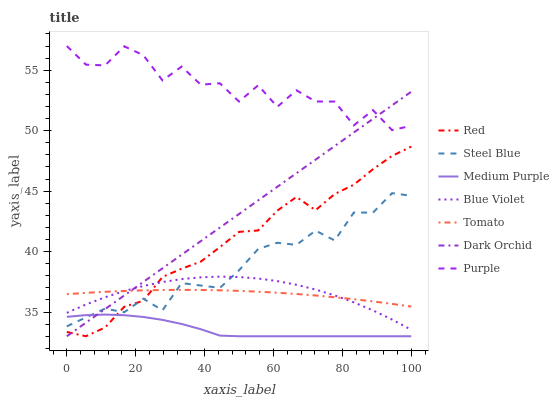Does Medium Purple have the minimum area under the curve?
Answer yes or no. Yes. Does Purple have the maximum area under the curve?
Answer yes or no. Yes. Does Steel Blue have the minimum area under the curve?
Answer yes or no. No. Does Steel Blue have the maximum area under the curve?
Answer yes or no. No. Is Dark Orchid the smoothest?
Answer yes or no. Yes. Is Purple the roughest?
Answer yes or no. Yes. Is Steel Blue the smoothest?
Answer yes or no. No. Is Steel Blue the roughest?
Answer yes or no. No. Does Dark Orchid have the lowest value?
Answer yes or no. Yes. Does Steel Blue have the lowest value?
Answer yes or no. No. Does Purple have the highest value?
Answer yes or no. Yes. Does Steel Blue have the highest value?
Answer yes or no. No. Is Tomato less than Purple?
Answer yes or no. Yes. Is Purple greater than Medium Purple?
Answer yes or no. Yes. Does Tomato intersect Blue Violet?
Answer yes or no. Yes. Is Tomato less than Blue Violet?
Answer yes or no. No. Is Tomato greater than Blue Violet?
Answer yes or no. No. Does Tomato intersect Purple?
Answer yes or no. No. 